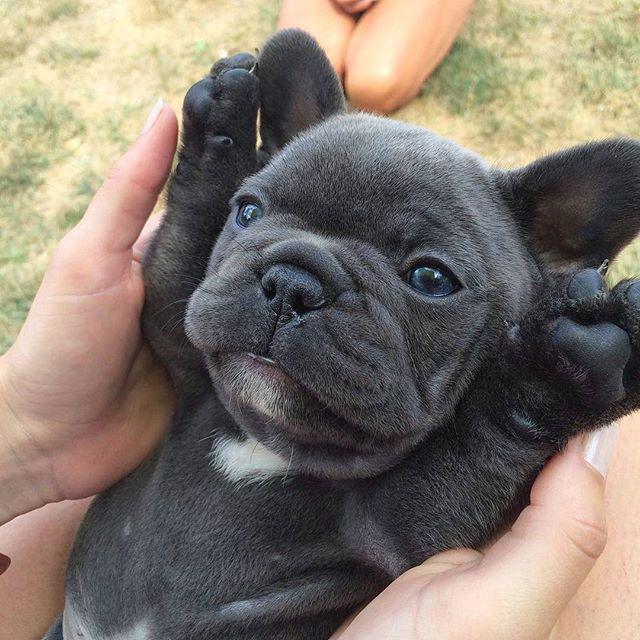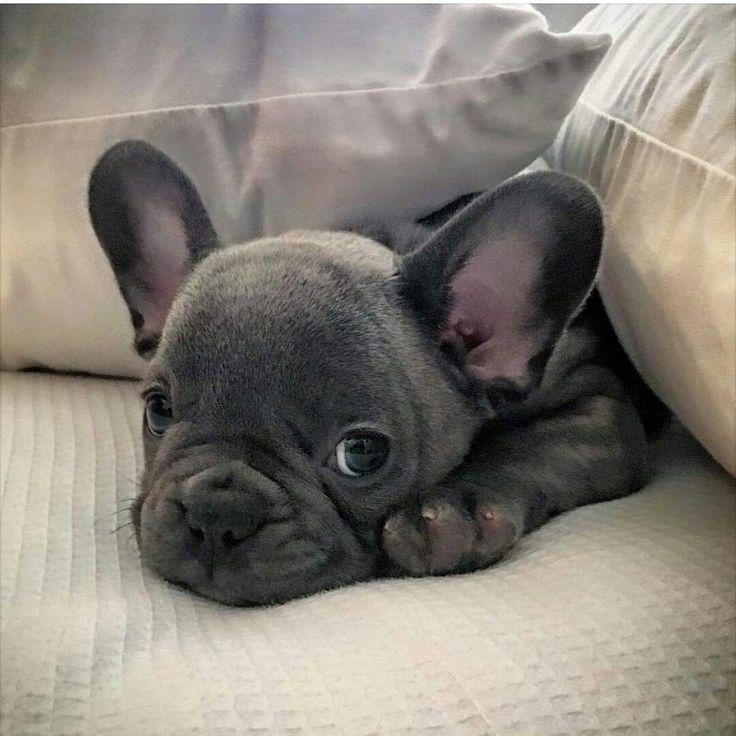The first image is the image on the left, the second image is the image on the right. For the images displayed, is the sentence "The left image features a dark big-eared puppy reclining on its belly with both paws forward and visible, with its body turned forward and its eyes glancing sideways." factually correct? Answer yes or no. No. The first image is the image on the left, the second image is the image on the right. Evaluate the accuracy of this statement regarding the images: "The dog in the image on the left is lying down.". Is it true? Answer yes or no. No. 